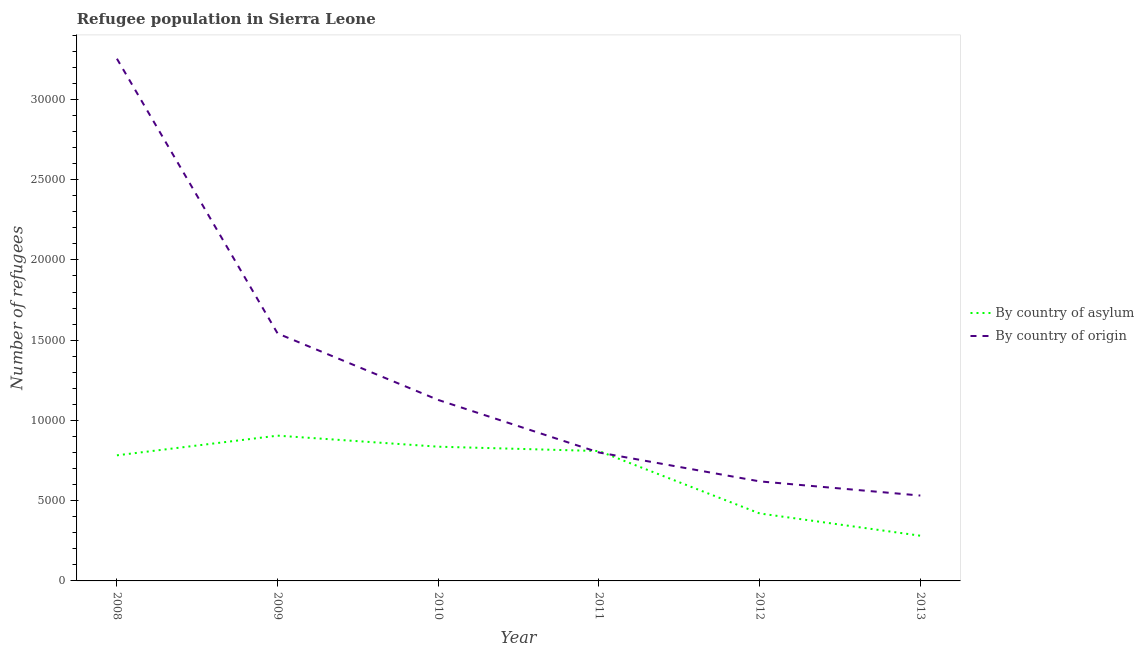How many different coloured lines are there?
Ensure brevity in your answer.  2. What is the number of refugees by country of origin in 2011?
Ensure brevity in your answer.  8002. Across all years, what is the maximum number of refugees by country of origin?
Your response must be concise. 3.25e+04. Across all years, what is the minimum number of refugees by country of origin?
Offer a terse response. 5320. In which year was the number of refugees by country of asylum minimum?
Give a very brief answer. 2013. What is the total number of refugees by country of asylum in the graph?
Offer a very short reply. 4.04e+04. What is the difference between the number of refugees by country of origin in 2008 and that in 2010?
Keep it short and to the point. 2.13e+04. What is the difference between the number of refugees by country of asylum in 2011 and the number of refugees by country of origin in 2013?
Your answer should be compact. 2772. What is the average number of refugees by country of asylum per year?
Your response must be concise. 6725.5. In the year 2012, what is the difference between the number of refugees by country of asylum and number of refugees by country of origin?
Your answer should be very brief. -1998. What is the ratio of the number of refugees by country of asylum in 2009 to that in 2013?
Give a very brief answer. 3.21. Is the number of refugees by country of asylum in 2010 less than that in 2013?
Provide a succinct answer. No. What is the difference between the highest and the second highest number of refugees by country of origin?
Give a very brief answer. 1.71e+04. What is the difference between the highest and the lowest number of refugees by country of origin?
Keep it short and to the point. 2.72e+04. In how many years, is the number of refugees by country of origin greater than the average number of refugees by country of origin taken over all years?
Give a very brief answer. 2. What is the difference between two consecutive major ticks on the Y-axis?
Provide a succinct answer. 5000. Are the values on the major ticks of Y-axis written in scientific E-notation?
Ensure brevity in your answer.  No. Does the graph contain any zero values?
Provide a short and direct response. No. How are the legend labels stacked?
Offer a terse response. Vertical. What is the title of the graph?
Your response must be concise. Refugee population in Sierra Leone. What is the label or title of the X-axis?
Keep it short and to the point. Year. What is the label or title of the Y-axis?
Offer a very short reply. Number of refugees. What is the Number of refugees of By country of asylum in 2008?
Offer a very short reply. 7826. What is the Number of refugees of By country of origin in 2008?
Provide a short and direct response. 3.25e+04. What is the Number of refugees of By country of asylum in 2009?
Make the answer very short. 9051. What is the Number of refugees of By country of origin in 2009?
Provide a short and direct response. 1.54e+04. What is the Number of refugees of By country of asylum in 2010?
Offer a terse response. 8363. What is the Number of refugees of By country of origin in 2010?
Offer a very short reply. 1.13e+04. What is the Number of refugees in By country of asylum in 2011?
Make the answer very short. 8092. What is the Number of refugees of By country of origin in 2011?
Your response must be concise. 8002. What is the Number of refugees in By country of asylum in 2012?
Your answer should be compact. 4204. What is the Number of refugees in By country of origin in 2012?
Offer a very short reply. 6202. What is the Number of refugees in By country of asylum in 2013?
Your response must be concise. 2817. What is the Number of refugees in By country of origin in 2013?
Give a very brief answer. 5320. Across all years, what is the maximum Number of refugees of By country of asylum?
Keep it short and to the point. 9051. Across all years, what is the maximum Number of refugees in By country of origin?
Provide a short and direct response. 3.25e+04. Across all years, what is the minimum Number of refugees in By country of asylum?
Your answer should be very brief. 2817. Across all years, what is the minimum Number of refugees in By country of origin?
Ensure brevity in your answer.  5320. What is the total Number of refugees of By country of asylum in the graph?
Your answer should be very brief. 4.04e+04. What is the total Number of refugees in By country of origin in the graph?
Offer a very short reply. 7.88e+04. What is the difference between the Number of refugees in By country of asylum in 2008 and that in 2009?
Offer a very short reply. -1225. What is the difference between the Number of refugees in By country of origin in 2008 and that in 2009?
Your response must be concise. 1.71e+04. What is the difference between the Number of refugees in By country of asylum in 2008 and that in 2010?
Provide a succinct answer. -537. What is the difference between the Number of refugees of By country of origin in 2008 and that in 2010?
Offer a terse response. 2.13e+04. What is the difference between the Number of refugees of By country of asylum in 2008 and that in 2011?
Make the answer very short. -266. What is the difference between the Number of refugees of By country of origin in 2008 and that in 2011?
Keep it short and to the point. 2.45e+04. What is the difference between the Number of refugees of By country of asylum in 2008 and that in 2012?
Provide a succinct answer. 3622. What is the difference between the Number of refugees of By country of origin in 2008 and that in 2012?
Keep it short and to the point. 2.63e+04. What is the difference between the Number of refugees of By country of asylum in 2008 and that in 2013?
Provide a short and direct response. 5009. What is the difference between the Number of refugees in By country of origin in 2008 and that in 2013?
Your answer should be compact. 2.72e+04. What is the difference between the Number of refugees of By country of asylum in 2009 and that in 2010?
Offer a terse response. 688. What is the difference between the Number of refugees of By country of origin in 2009 and that in 2010?
Ensure brevity in your answer.  4142. What is the difference between the Number of refugees in By country of asylum in 2009 and that in 2011?
Provide a short and direct response. 959. What is the difference between the Number of refugees of By country of origin in 2009 and that in 2011?
Give a very brief answer. 7415. What is the difference between the Number of refugees in By country of asylum in 2009 and that in 2012?
Your response must be concise. 4847. What is the difference between the Number of refugees in By country of origin in 2009 and that in 2012?
Offer a terse response. 9215. What is the difference between the Number of refugees in By country of asylum in 2009 and that in 2013?
Your answer should be very brief. 6234. What is the difference between the Number of refugees in By country of origin in 2009 and that in 2013?
Provide a short and direct response. 1.01e+04. What is the difference between the Number of refugees of By country of asylum in 2010 and that in 2011?
Make the answer very short. 271. What is the difference between the Number of refugees of By country of origin in 2010 and that in 2011?
Your answer should be compact. 3273. What is the difference between the Number of refugees of By country of asylum in 2010 and that in 2012?
Make the answer very short. 4159. What is the difference between the Number of refugees in By country of origin in 2010 and that in 2012?
Your answer should be very brief. 5073. What is the difference between the Number of refugees of By country of asylum in 2010 and that in 2013?
Provide a succinct answer. 5546. What is the difference between the Number of refugees in By country of origin in 2010 and that in 2013?
Ensure brevity in your answer.  5955. What is the difference between the Number of refugees in By country of asylum in 2011 and that in 2012?
Ensure brevity in your answer.  3888. What is the difference between the Number of refugees in By country of origin in 2011 and that in 2012?
Give a very brief answer. 1800. What is the difference between the Number of refugees in By country of asylum in 2011 and that in 2013?
Keep it short and to the point. 5275. What is the difference between the Number of refugees of By country of origin in 2011 and that in 2013?
Your response must be concise. 2682. What is the difference between the Number of refugees of By country of asylum in 2012 and that in 2013?
Offer a terse response. 1387. What is the difference between the Number of refugees in By country of origin in 2012 and that in 2013?
Keep it short and to the point. 882. What is the difference between the Number of refugees in By country of asylum in 2008 and the Number of refugees in By country of origin in 2009?
Your response must be concise. -7591. What is the difference between the Number of refugees of By country of asylum in 2008 and the Number of refugees of By country of origin in 2010?
Your response must be concise. -3449. What is the difference between the Number of refugees in By country of asylum in 2008 and the Number of refugees in By country of origin in 2011?
Give a very brief answer. -176. What is the difference between the Number of refugees in By country of asylum in 2008 and the Number of refugees in By country of origin in 2012?
Ensure brevity in your answer.  1624. What is the difference between the Number of refugees in By country of asylum in 2008 and the Number of refugees in By country of origin in 2013?
Make the answer very short. 2506. What is the difference between the Number of refugees in By country of asylum in 2009 and the Number of refugees in By country of origin in 2010?
Keep it short and to the point. -2224. What is the difference between the Number of refugees in By country of asylum in 2009 and the Number of refugees in By country of origin in 2011?
Ensure brevity in your answer.  1049. What is the difference between the Number of refugees in By country of asylum in 2009 and the Number of refugees in By country of origin in 2012?
Your answer should be very brief. 2849. What is the difference between the Number of refugees in By country of asylum in 2009 and the Number of refugees in By country of origin in 2013?
Ensure brevity in your answer.  3731. What is the difference between the Number of refugees in By country of asylum in 2010 and the Number of refugees in By country of origin in 2011?
Make the answer very short. 361. What is the difference between the Number of refugees in By country of asylum in 2010 and the Number of refugees in By country of origin in 2012?
Your answer should be very brief. 2161. What is the difference between the Number of refugees in By country of asylum in 2010 and the Number of refugees in By country of origin in 2013?
Offer a terse response. 3043. What is the difference between the Number of refugees in By country of asylum in 2011 and the Number of refugees in By country of origin in 2012?
Offer a very short reply. 1890. What is the difference between the Number of refugees of By country of asylum in 2011 and the Number of refugees of By country of origin in 2013?
Provide a succinct answer. 2772. What is the difference between the Number of refugees in By country of asylum in 2012 and the Number of refugees in By country of origin in 2013?
Your response must be concise. -1116. What is the average Number of refugees of By country of asylum per year?
Give a very brief answer. 6725.5. What is the average Number of refugees of By country of origin per year?
Your answer should be compact. 1.31e+04. In the year 2008, what is the difference between the Number of refugees in By country of asylum and Number of refugees in By country of origin?
Provide a succinct answer. -2.47e+04. In the year 2009, what is the difference between the Number of refugees of By country of asylum and Number of refugees of By country of origin?
Offer a very short reply. -6366. In the year 2010, what is the difference between the Number of refugees of By country of asylum and Number of refugees of By country of origin?
Provide a succinct answer. -2912. In the year 2011, what is the difference between the Number of refugees in By country of asylum and Number of refugees in By country of origin?
Give a very brief answer. 90. In the year 2012, what is the difference between the Number of refugees of By country of asylum and Number of refugees of By country of origin?
Provide a short and direct response. -1998. In the year 2013, what is the difference between the Number of refugees of By country of asylum and Number of refugees of By country of origin?
Your answer should be compact. -2503. What is the ratio of the Number of refugees in By country of asylum in 2008 to that in 2009?
Your answer should be very brief. 0.86. What is the ratio of the Number of refugees in By country of origin in 2008 to that in 2009?
Give a very brief answer. 2.11. What is the ratio of the Number of refugees in By country of asylum in 2008 to that in 2010?
Provide a succinct answer. 0.94. What is the ratio of the Number of refugees in By country of origin in 2008 to that in 2010?
Make the answer very short. 2.89. What is the ratio of the Number of refugees in By country of asylum in 2008 to that in 2011?
Provide a short and direct response. 0.97. What is the ratio of the Number of refugees of By country of origin in 2008 to that in 2011?
Offer a very short reply. 4.07. What is the ratio of the Number of refugees in By country of asylum in 2008 to that in 2012?
Offer a very short reply. 1.86. What is the ratio of the Number of refugees of By country of origin in 2008 to that in 2012?
Offer a terse response. 5.25. What is the ratio of the Number of refugees of By country of asylum in 2008 to that in 2013?
Your answer should be compact. 2.78. What is the ratio of the Number of refugees in By country of origin in 2008 to that in 2013?
Provide a short and direct response. 6.12. What is the ratio of the Number of refugees in By country of asylum in 2009 to that in 2010?
Your answer should be compact. 1.08. What is the ratio of the Number of refugees of By country of origin in 2009 to that in 2010?
Your response must be concise. 1.37. What is the ratio of the Number of refugees in By country of asylum in 2009 to that in 2011?
Your answer should be very brief. 1.12. What is the ratio of the Number of refugees in By country of origin in 2009 to that in 2011?
Your answer should be compact. 1.93. What is the ratio of the Number of refugees in By country of asylum in 2009 to that in 2012?
Give a very brief answer. 2.15. What is the ratio of the Number of refugees in By country of origin in 2009 to that in 2012?
Ensure brevity in your answer.  2.49. What is the ratio of the Number of refugees of By country of asylum in 2009 to that in 2013?
Provide a short and direct response. 3.21. What is the ratio of the Number of refugees in By country of origin in 2009 to that in 2013?
Ensure brevity in your answer.  2.9. What is the ratio of the Number of refugees of By country of asylum in 2010 to that in 2011?
Your answer should be very brief. 1.03. What is the ratio of the Number of refugees in By country of origin in 2010 to that in 2011?
Your response must be concise. 1.41. What is the ratio of the Number of refugees of By country of asylum in 2010 to that in 2012?
Make the answer very short. 1.99. What is the ratio of the Number of refugees of By country of origin in 2010 to that in 2012?
Your answer should be very brief. 1.82. What is the ratio of the Number of refugees of By country of asylum in 2010 to that in 2013?
Offer a terse response. 2.97. What is the ratio of the Number of refugees of By country of origin in 2010 to that in 2013?
Give a very brief answer. 2.12. What is the ratio of the Number of refugees in By country of asylum in 2011 to that in 2012?
Your answer should be compact. 1.92. What is the ratio of the Number of refugees of By country of origin in 2011 to that in 2012?
Your answer should be very brief. 1.29. What is the ratio of the Number of refugees in By country of asylum in 2011 to that in 2013?
Provide a succinct answer. 2.87. What is the ratio of the Number of refugees of By country of origin in 2011 to that in 2013?
Your answer should be compact. 1.5. What is the ratio of the Number of refugees of By country of asylum in 2012 to that in 2013?
Your answer should be very brief. 1.49. What is the ratio of the Number of refugees in By country of origin in 2012 to that in 2013?
Provide a succinct answer. 1.17. What is the difference between the highest and the second highest Number of refugees in By country of asylum?
Provide a short and direct response. 688. What is the difference between the highest and the second highest Number of refugees of By country of origin?
Your answer should be compact. 1.71e+04. What is the difference between the highest and the lowest Number of refugees of By country of asylum?
Your answer should be very brief. 6234. What is the difference between the highest and the lowest Number of refugees in By country of origin?
Ensure brevity in your answer.  2.72e+04. 